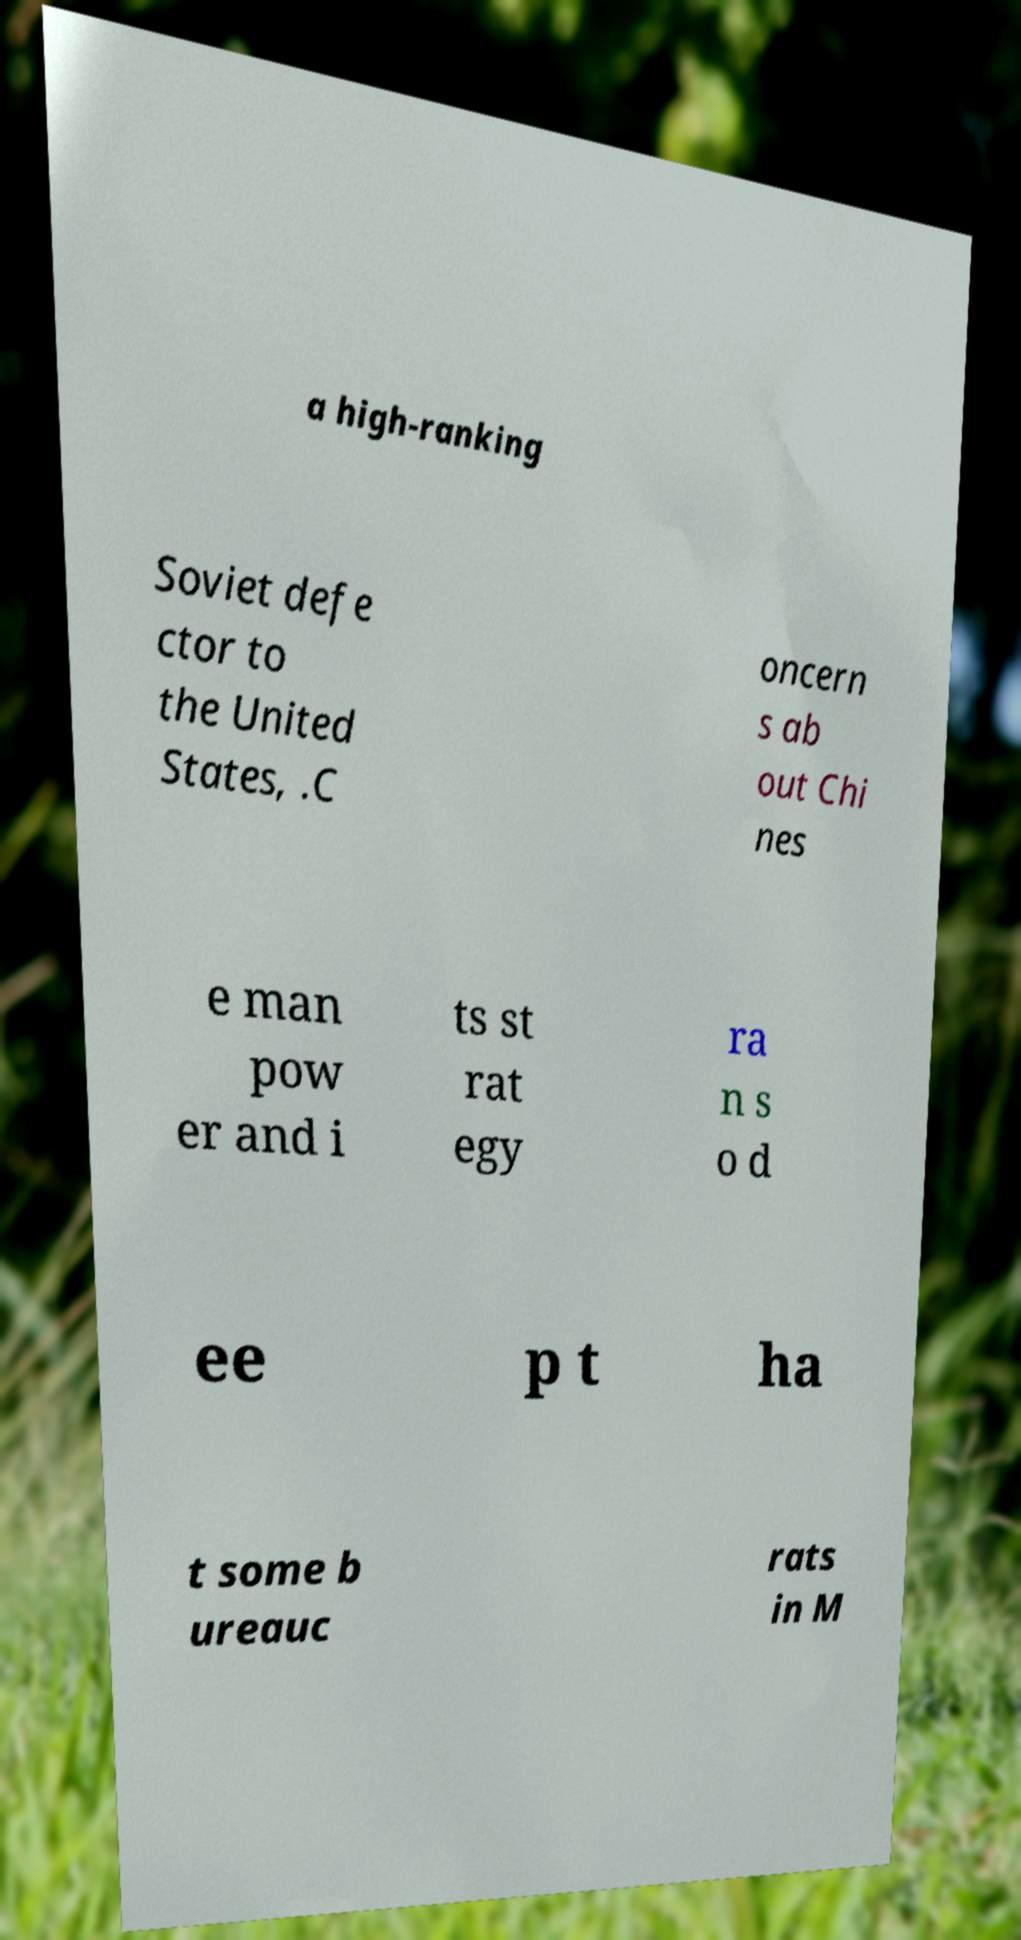There's text embedded in this image that I need extracted. Can you transcribe it verbatim? a high-ranking Soviet defe ctor to the United States, .C oncern s ab out Chi nes e man pow er and i ts st rat egy ra n s o d ee p t ha t some b ureauc rats in M 